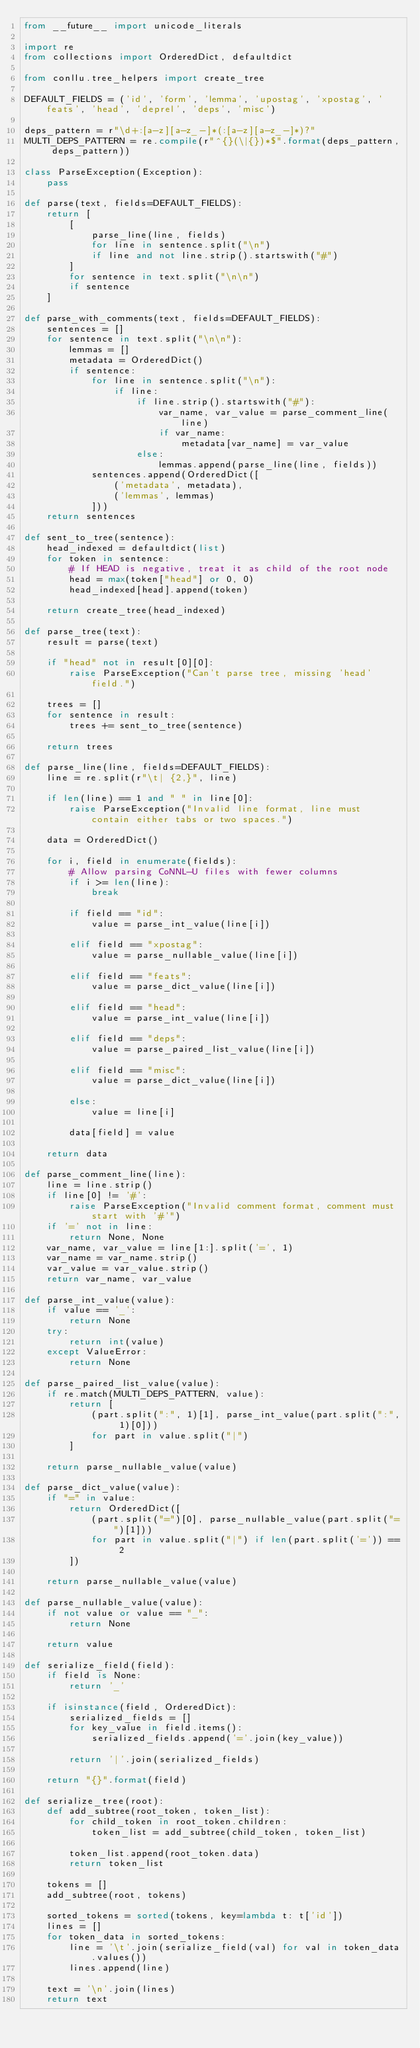<code> <loc_0><loc_0><loc_500><loc_500><_Python_>from __future__ import unicode_literals

import re
from collections import OrderedDict, defaultdict

from conllu.tree_helpers import create_tree

DEFAULT_FIELDS = ('id', 'form', 'lemma', 'upostag', 'xpostag', 'feats', 'head', 'deprel', 'deps', 'misc')

deps_pattern = r"\d+:[a-z][a-z_-]*(:[a-z][a-z_-]*)?"
MULTI_DEPS_PATTERN = re.compile(r"^{}(\|{})*$".format(deps_pattern, deps_pattern))

class ParseException(Exception):
    pass

def parse(text, fields=DEFAULT_FIELDS):
    return [
        [
            parse_line(line, fields)
            for line in sentence.split("\n")
            if line and not line.strip().startswith("#")
        ]
        for sentence in text.split("\n\n")
        if sentence
    ]

def parse_with_comments(text, fields=DEFAULT_FIELDS):
    sentences = []
    for sentence in text.split("\n\n"):
        lemmas = []
        metadata = OrderedDict()
        if sentence:
            for line in sentence.split("\n"):
                if line:
                    if line.strip().startswith("#"):
                        var_name, var_value = parse_comment_line(line)
                        if var_name:
                            metadata[var_name] = var_value
                    else:
                        lemmas.append(parse_line(line, fields))
            sentences.append(OrderedDict([
                ('metadata', metadata),
                ('lemmas', lemmas)
            ]))
    return sentences

def sent_to_tree(sentence):
    head_indexed = defaultdict(list)
    for token in sentence:
        # If HEAD is negative, treat it as child of the root node
        head = max(token["head"] or 0, 0)
        head_indexed[head].append(token)

    return create_tree(head_indexed)

def parse_tree(text):
    result = parse(text)

    if "head" not in result[0][0]:
        raise ParseException("Can't parse tree, missing 'head' field.")

    trees = []
    for sentence in result:
        trees += sent_to_tree(sentence)

    return trees

def parse_line(line, fields=DEFAULT_FIELDS):
    line = re.split(r"\t| {2,}", line)

    if len(line) == 1 and " " in line[0]:
        raise ParseException("Invalid line format, line must contain either tabs or two spaces.")

    data = OrderedDict()

    for i, field in enumerate(fields):
        # Allow parsing CoNNL-U files with fewer columns
        if i >= len(line):
            break

        if field == "id":
            value = parse_int_value(line[i])

        elif field == "xpostag":
            value = parse_nullable_value(line[i])

        elif field == "feats":
            value = parse_dict_value(line[i])

        elif field == "head":
            value = parse_int_value(line[i])

        elif field == "deps":
            value = parse_paired_list_value(line[i])

        elif field == "misc":
            value = parse_dict_value(line[i])

        else:
            value = line[i]

        data[field] = value

    return data

def parse_comment_line(line):
    line = line.strip()
    if line[0] != '#':
        raise ParseException("Invalid comment format, comment must start with '#'")
    if '=' not in line:
        return None, None
    var_name, var_value = line[1:].split('=', 1)
    var_name = var_name.strip()
    var_value = var_value.strip()
    return var_name, var_value

def parse_int_value(value):
    if value == '_':
        return None
    try:
        return int(value)
    except ValueError:
        return None

def parse_paired_list_value(value):
    if re.match(MULTI_DEPS_PATTERN, value):
        return [
            (part.split(":", 1)[1], parse_int_value(part.split(":", 1)[0]))
            for part in value.split("|")
        ]

    return parse_nullable_value(value)

def parse_dict_value(value):
    if "=" in value:
        return OrderedDict([
            (part.split("=")[0], parse_nullable_value(part.split("=")[1]))
            for part in value.split("|") if len(part.split('=')) == 2
        ])

    return parse_nullable_value(value)

def parse_nullable_value(value):
    if not value or value == "_":
        return None

    return value

def serialize_field(field):
    if field is None:
        return '_'

    if isinstance(field, OrderedDict):
        serialized_fields = []
        for key_value in field.items():
            serialized_fields.append('='.join(key_value))

        return '|'.join(serialized_fields)

    return "{}".format(field)

def serialize_tree(root):
    def add_subtree(root_token, token_list):
        for child_token in root_token.children:
            token_list = add_subtree(child_token, token_list)

        token_list.append(root_token.data)
        return token_list

    tokens = []
    add_subtree(root, tokens)

    sorted_tokens = sorted(tokens, key=lambda t: t['id'])
    lines = []
    for token_data in sorted_tokens:
        line = '\t'.join(serialize_field(val) for val in token_data.values())
        lines.append(line)

    text = '\n'.join(lines)
    return text
</code> 